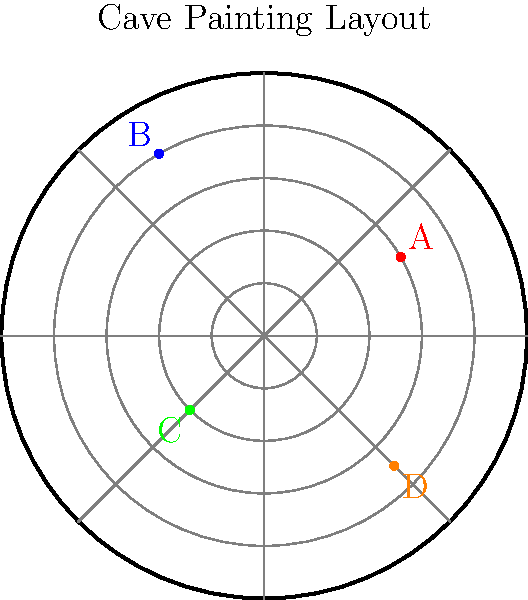In the circular cave painting shown above, four significant figures (A, B, C, and D) have been identified. Which figure is located at approximately $(r, \theta) = (3.5, 315°)$ in polar coordinates? To answer this question, we need to understand how polar coordinates work and then identify the figure that matches the given coordinates. Let's break it down step-by-step:

1. Polar coordinates consist of two components:
   - $r$: the radial distance from the center
   - $\theta$: the angle from the positive x-axis (measured counterclockwise)

2. The given coordinates are $(r, \theta) = (3.5, 315°)$:
   - $r = 3.5$ means the figure is 3.5 units away from the center
   - $\theta = 315°$ means the angle is 315° from the positive x-axis

3. 315° is equivalent to the 10:30 position on a clock face (since 360° ÷ 12 = 30° per hour, and 315° ÷ 30° = 10.5 hours)

4. Looking at the diagram, we can see that:
   - Figure A is at about 30°
   - Figure B is at about 120°
   - Figure C is at about 225°
   - Figure D is at about 315°

5. We can also observe that figure D is between the 3rd and 4th concentric circles, which corresponds to a radial distance of about 3.5 units.

6. Therefore, the figure located at approximately $(3.5, 315°)$ is figure D.
Answer: D 